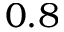Convert formula to latex. <formula><loc_0><loc_0><loc_500><loc_500>0 . 8</formula> 